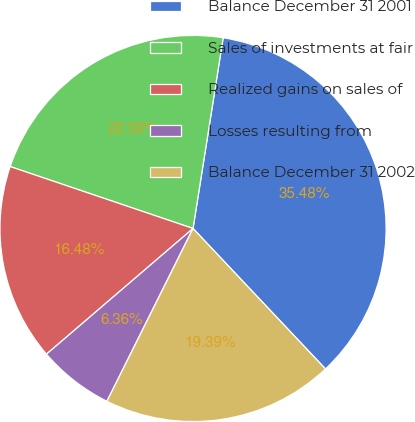Convert chart. <chart><loc_0><loc_0><loc_500><loc_500><pie_chart><fcel>Balance December 31 2001<fcel>Sales of investments at fair<fcel>Realized gains on sales of<fcel>Losses resulting from<fcel>Balance December 31 2002<nl><fcel>35.48%<fcel>22.3%<fcel>16.48%<fcel>6.36%<fcel>19.39%<nl></chart> 